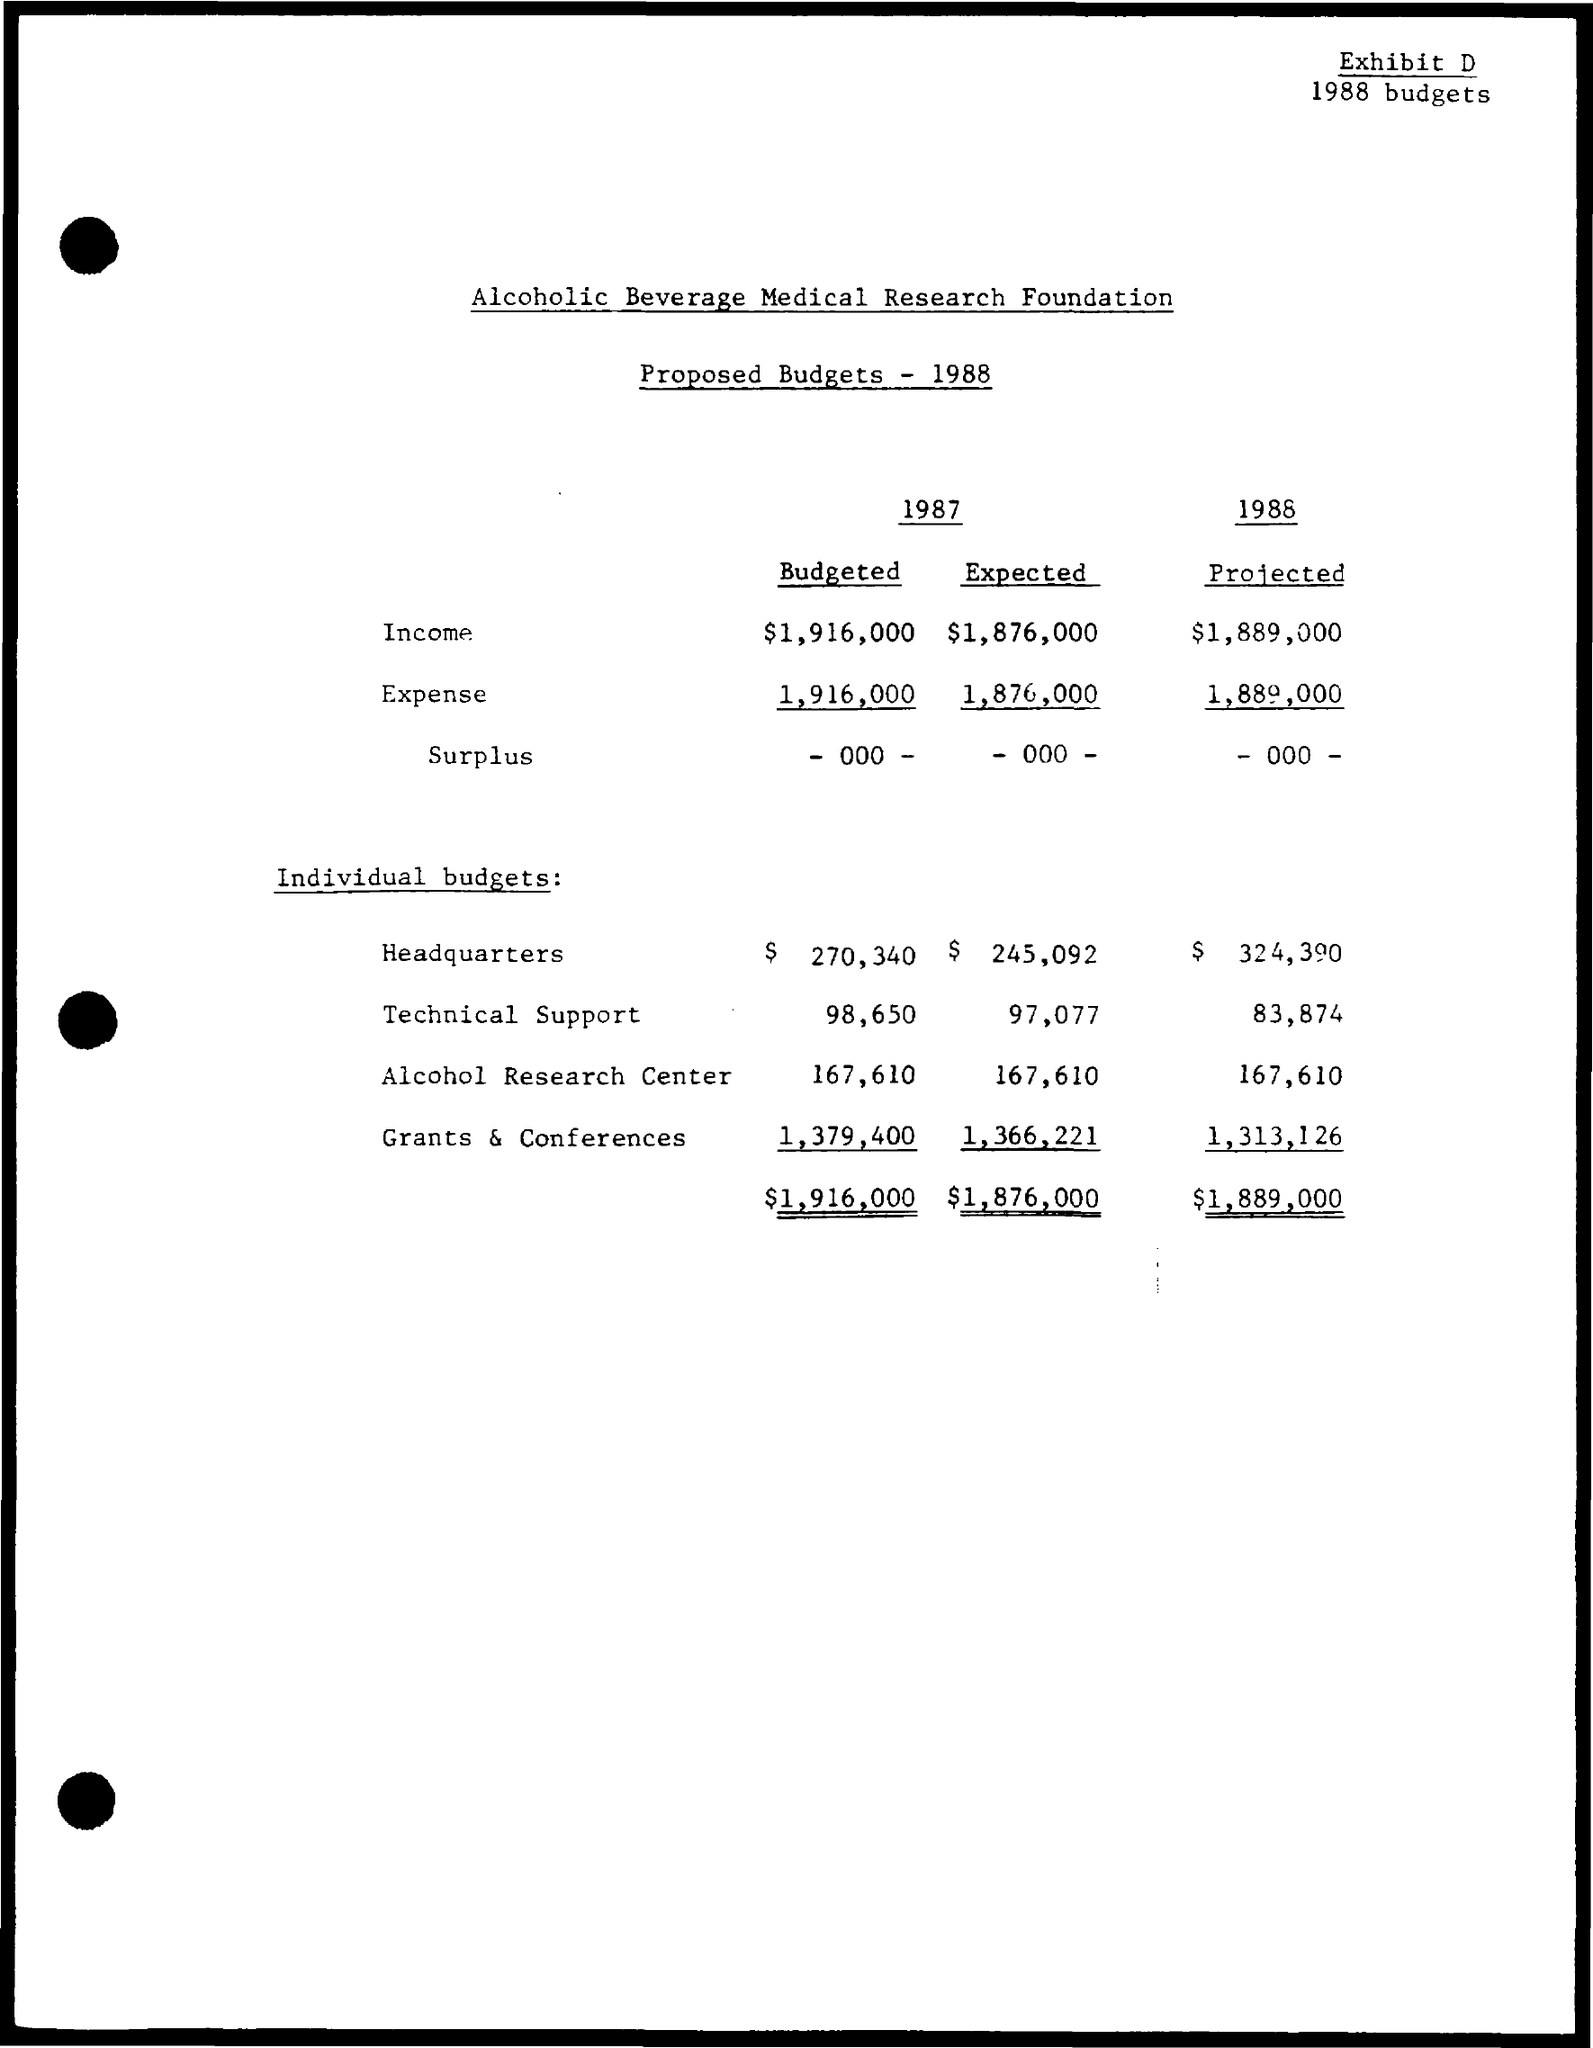Mention a couple of crucial points in this snapshot. The projected income for the year 1988 is expected to be $1,889,000. The proposed budget of the Alcoholic Beverage Medical Research Foundation is provided. The budgeted expense for the year 1987 is $1,916,000. The estimated budget for the Alcohol Research Center for the year 1987 is 167,610. The projected budget for technical support in the year 1988 is expected to be 83,874. 